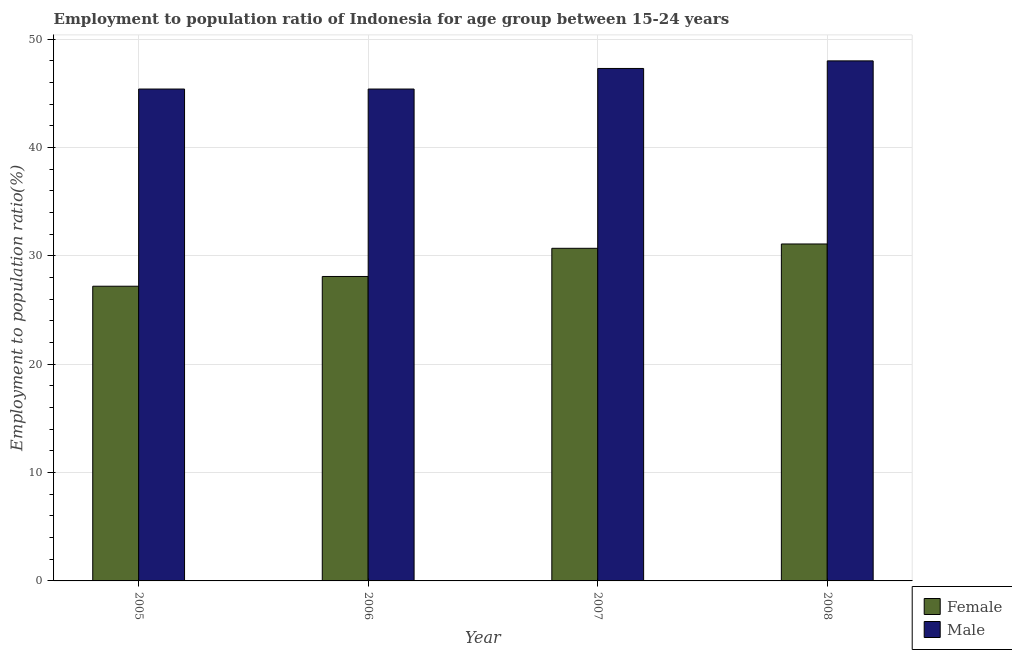How many groups of bars are there?
Provide a succinct answer. 4. Are the number of bars per tick equal to the number of legend labels?
Your answer should be compact. Yes. How many bars are there on the 4th tick from the left?
Provide a succinct answer. 2. How many bars are there on the 4th tick from the right?
Make the answer very short. 2. In how many cases, is the number of bars for a given year not equal to the number of legend labels?
Offer a very short reply. 0. What is the employment to population ratio(male) in 2005?
Keep it short and to the point. 45.4. Across all years, what is the maximum employment to population ratio(male)?
Ensure brevity in your answer.  48. Across all years, what is the minimum employment to population ratio(female)?
Offer a terse response. 27.2. In which year was the employment to population ratio(female) minimum?
Provide a short and direct response. 2005. What is the total employment to population ratio(male) in the graph?
Make the answer very short. 186.1. What is the difference between the employment to population ratio(female) in 2005 and that in 2008?
Your response must be concise. -3.9. What is the difference between the employment to population ratio(female) in 2005 and the employment to population ratio(male) in 2006?
Keep it short and to the point. -0.9. What is the average employment to population ratio(female) per year?
Keep it short and to the point. 29.28. In the year 2005, what is the difference between the employment to population ratio(female) and employment to population ratio(male)?
Your answer should be very brief. 0. In how many years, is the employment to population ratio(male) greater than 16 %?
Your response must be concise. 4. What is the ratio of the employment to population ratio(female) in 2006 to that in 2007?
Offer a very short reply. 0.92. Is the employment to population ratio(male) in 2007 less than that in 2008?
Your answer should be compact. Yes. What is the difference between the highest and the second highest employment to population ratio(male)?
Offer a very short reply. 0.7. What is the difference between the highest and the lowest employment to population ratio(female)?
Your response must be concise. 3.9. In how many years, is the employment to population ratio(female) greater than the average employment to population ratio(female) taken over all years?
Provide a succinct answer. 2. What does the 1st bar from the left in 2008 represents?
Offer a very short reply. Female. What does the 2nd bar from the right in 2005 represents?
Give a very brief answer. Female. How many bars are there?
Ensure brevity in your answer.  8. Are all the bars in the graph horizontal?
Provide a short and direct response. No. Are the values on the major ticks of Y-axis written in scientific E-notation?
Your response must be concise. No. Does the graph contain grids?
Ensure brevity in your answer.  Yes. How many legend labels are there?
Your response must be concise. 2. How are the legend labels stacked?
Your answer should be very brief. Vertical. What is the title of the graph?
Give a very brief answer. Employment to population ratio of Indonesia for age group between 15-24 years. Does "Grants" appear as one of the legend labels in the graph?
Ensure brevity in your answer.  No. What is the Employment to population ratio(%) in Female in 2005?
Ensure brevity in your answer.  27.2. What is the Employment to population ratio(%) in Male in 2005?
Your answer should be compact. 45.4. What is the Employment to population ratio(%) of Female in 2006?
Give a very brief answer. 28.1. What is the Employment to population ratio(%) in Male in 2006?
Your answer should be compact. 45.4. What is the Employment to population ratio(%) of Female in 2007?
Your answer should be very brief. 30.7. What is the Employment to population ratio(%) of Male in 2007?
Provide a succinct answer. 47.3. What is the Employment to population ratio(%) of Female in 2008?
Offer a terse response. 31.1. Across all years, what is the maximum Employment to population ratio(%) in Female?
Ensure brevity in your answer.  31.1. Across all years, what is the maximum Employment to population ratio(%) of Male?
Give a very brief answer. 48. Across all years, what is the minimum Employment to population ratio(%) in Female?
Make the answer very short. 27.2. Across all years, what is the minimum Employment to population ratio(%) in Male?
Your answer should be compact. 45.4. What is the total Employment to population ratio(%) of Female in the graph?
Offer a very short reply. 117.1. What is the total Employment to population ratio(%) of Male in the graph?
Ensure brevity in your answer.  186.1. What is the difference between the Employment to population ratio(%) in Male in 2005 and that in 2006?
Make the answer very short. 0. What is the difference between the Employment to population ratio(%) in Female in 2005 and that in 2007?
Provide a short and direct response. -3.5. What is the difference between the Employment to population ratio(%) of Female in 2005 and that in 2008?
Provide a short and direct response. -3.9. What is the difference between the Employment to population ratio(%) in Male in 2005 and that in 2008?
Give a very brief answer. -2.6. What is the difference between the Employment to population ratio(%) in Female in 2006 and that in 2007?
Make the answer very short. -2.6. What is the difference between the Employment to population ratio(%) in Male in 2006 and that in 2007?
Provide a succinct answer. -1.9. What is the difference between the Employment to population ratio(%) in Male in 2006 and that in 2008?
Keep it short and to the point. -2.6. What is the difference between the Employment to population ratio(%) in Female in 2007 and that in 2008?
Your response must be concise. -0.4. What is the difference between the Employment to population ratio(%) in Male in 2007 and that in 2008?
Provide a succinct answer. -0.7. What is the difference between the Employment to population ratio(%) in Female in 2005 and the Employment to population ratio(%) in Male in 2006?
Provide a succinct answer. -18.2. What is the difference between the Employment to population ratio(%) in Female in 2005 and the Employment to population ratio(%) in Male in 2007?
Your answer should be very brief. -20.1. What is the difference between the Employment to population ratio(%) of Female in 2005 and the Employment to population ratio(%) of Male in 2008?
Your answer should be very brief. -20.8. What is the difference between the Employment to population ratio(%) of Female in 2006 and the Employment to population ratio(%) of Male in 2007?
Provide a short and direct response. -19.2. What is the difference between the Employment to population ratio(%) in Female in 2006 and the Employment to population ratio(%) in Male in 2008?
Make the answer very short. -19.9. What is the difference between the Employment to population ratio(%) of Female in 2007 and the Employment to population ratio(%) of Male in 2008?
Ensure brevity in your answer.  -17.3. What is the average Employment to population ratio(%) of Female per year?
Keep it short and to the point. 29.27. What is the average Employment to population ratio(%) in Male per year?
Your answer should be compact. 46.52. In the year 2005, what is the difference between the Employment to population ratio(%) of Female and Employment to population ratio(%) of Male?
Keep it short and to the point. -18.2. In the year 2006, what is the difference between the Employment to population ratio(%) in Female and Employment to population ratio(%) in Male?
Keep it short and to the point. -17.3. In the year 2007, what is the difference between the Employment to population ratio(%) in Female and Employment to population ratio(%) in Male?
Your answer should be compact. -16.6. In the year 2008, what is the difference between the Employment to population ratio(%) in Female and Employment to population ratio(%) in Male?
Your response must be concise. -16.9. What is the ratio of the Employment to population ratio(%) of Female in 2005 to that in 2006?
Your response must be concise. 0.97. What is the ratio of the Employment to population ratio(%) of Male in 2005 to that in 2006?
Offer a terse response. 1. What is the ratio of the Employment to population ratio(%) in Female in 2005 to that in 2007?
Ensure brevity in your answer.  0.89. What is the ratio of the Employment to population ratio(%) of Male in 2005 to that in 2007?
Ensure brevity in your answer.  0.96. What is the ratio of the Employment to population ratio(%) in Female in 2005 to that in 2008?
Offer a terse response. 0.87. What is the ratio of the Employment to population ratio(%) in Male in 2005 to that in 2008?
Provide a short and direct response. 0.95. What is the ratio of the Employment to population ratio(%) in Female in 2006 to that in 2007?
Offer a very short reply. 0.92. What is the ratio of the Employment to population ratio(%) in Male in 2006 to that in 2007?
Your answer should be very brief. 0.96. What is the ratio of the Employment to population ratio(%) of Female in 2006 to that in 2008?
Offer a terse response. 0.9. What is the ratio of the Employment to population ratio(%) in Male in 2006 to that in 2008?
Your response must be concise. 0.95. What is the ratio of the Employment to population ratio(%) in Female in 2007 to that in 2008?
Give a very brief answer. 0.99. What is the ratio of the Employment to population ratio(%) in Male in 2007 to that in 2008?
Your answer should be very brief. 0.99. What is the difference between the highest and the lowest Employment to population ratio(%) in Female?
Give a very brief answer. 3.9. 